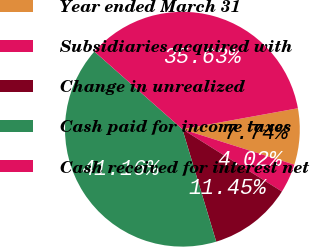Convert chart to OTSL. <chart><loc_0><loc_0><loc_500><loc_500><pie_chart><fcel>Year ended March 31<fcel>Subsidiaries acquired with<fcel>Change in unrealized<fcel>Cash paid for income taxes<fcel>Cash received for interest net<nl><fcel>7.74%<fcel>4.02%<fcel>11.45%<fcel>41.16%<fcel>35.63%<nl></chart> 